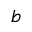Convert formula to latex. <formula><loc_0><loc_0><loc_500><loc_500>b</formula> 